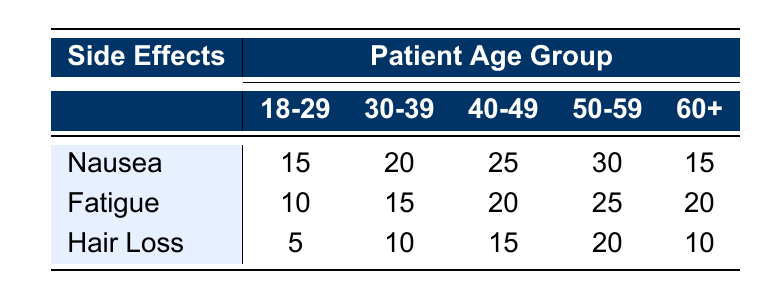What is the count of patients aged 30-39 who experienced nausea? Referring to the table, the count of patients aged 30-39 who experienced nausea is directly listed in the relevant cell under the nausea row and 30-39 column.
Answer: 20 What is the total number of patients aged 60 and above who experienced fatigue? To find this, I will add the counts of fatigue for the age groups 60+. The count for that age group is 20. Since this is for only one age group, the total is the same.
Answer: 20 How many patients in the 50-59 age group experienced hair loss? The table shows that for the 50-59 age group, the cell corresponding to hair loss indicates a count. I refer to that specific cell under the hair loss row and 50-59 column.
Answer: 20 Which side effect is most common among patients aged 40-49? To determine the most common side effect for the 40-49 age group, I look at the counts of nausea, fatigue, and hair loss listed in the table. The highest count in this row is 25 for nausea.
Answer: Nausea Is it true that more patients in the 18-29 age group experienced fatigue than those aged 60+? I have to compare the counts of fatigue for both age groups. For 18-29, the count is 10, while for 60+, it is 20. Since 10 is less than 20, the statement is false.
Answer: No What is the average count of hair loss experienced across all age groups? I calculate the average by summing the counts of hair loss across all age groups: (5 + 10 + 15 + 20 + 10) = 70. Then, I divide by the number of age groups, which is 5: 70 / 5 = 14.
Answer: 14 How many more patients in the 50-59 age group experienced nausea compared to those aged 18-29? To answer this, I first find the counts of nausea for both age groups: 50-59 has 30 and 18-29 has 15. I then subtract the two: 30 - 15 = 15.
Answer: 15 What is the total count of side effects experienced by patients aged 30-39? I would add the count of all side effects experienced by this age group: Nausea (20) + Fatigue (15) + Hair Loss (10) = 45.
Answer: 45 